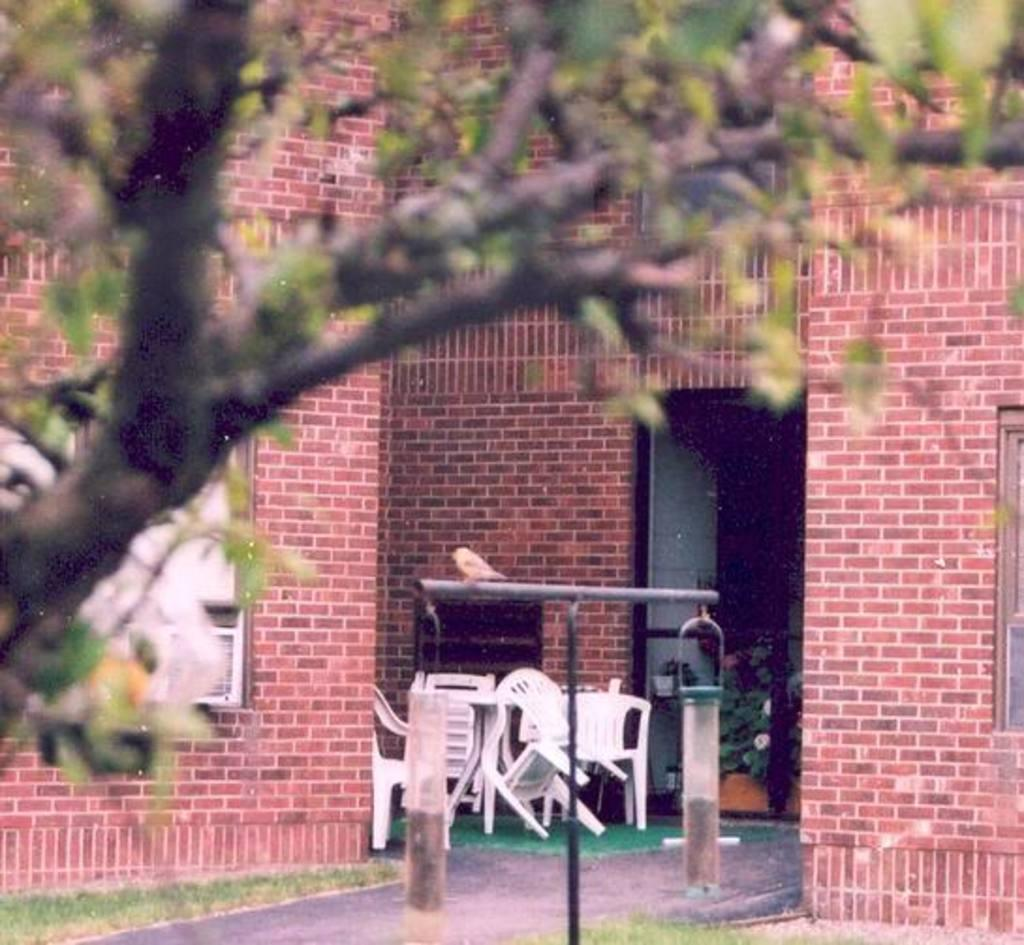What is located in the foreground of the image? There is a tree in the foreground of the image. What can be seen in the background of the image? There is a red color brick wall and chairs in the background of the image. Can you describe the condition of the rabbit in the image? There is no rabbit present in the image. How many people are walking in the image? There is no indication of people walking in the image. 